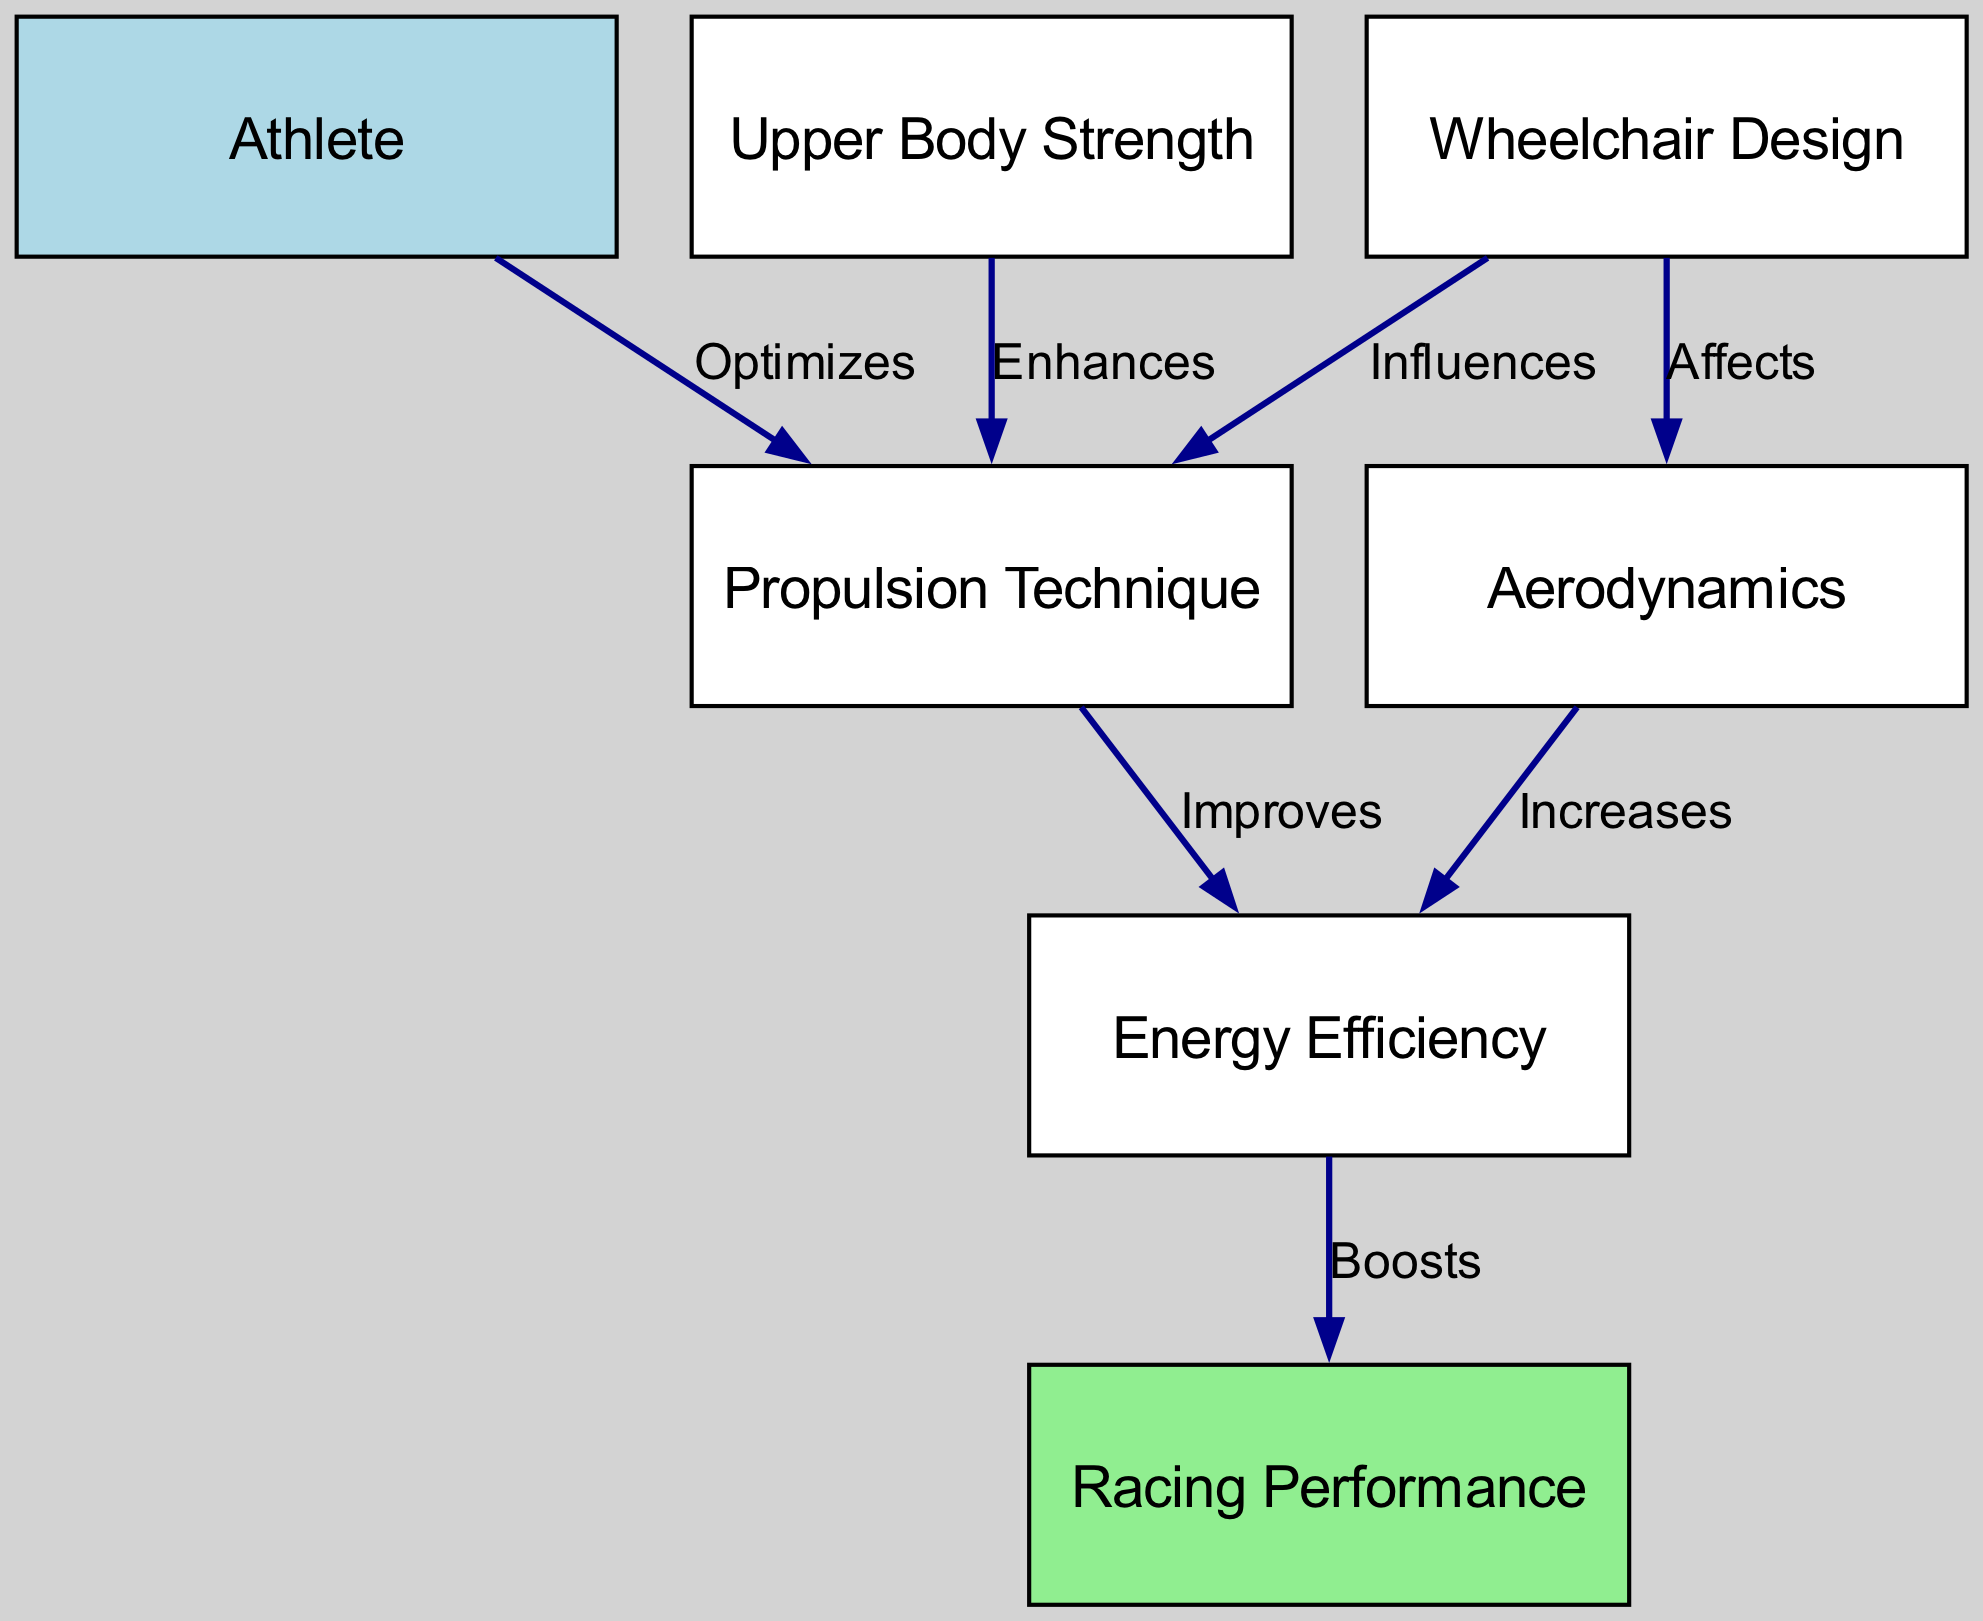What node represents the athlete? In the diagram, the node labeled "Athlete" has the ID "1". Thus, it directly represents the athlete in wheelchair racing.
Answer: Athlete How many nodes are present in the diagram? The diagram contains seven nodes that represent various components involved in wheelchair racing biomechanics.
Answer: Seven Which node influences the propulsion technique? The "Wheelchair Design" node, with ID "2", influences the "Propulsion Technique" node, as indicated by the edge labeled "Influences" connecting them.
Answer: Wheelchair Design What aspect does upper body strength enhance? Upper Body Strength enhances the Propulsion Technique, based on the edge labeled "Enhances" that connects Upper Body Strength to Propulsion Technique.
Answer: Propulsion Technique What is the relationship between aerodynamics and energy efficiency? The relationship is that aerodynamics increases energy efficiency, shown by the edge labeled "Increases" connecting Aerodynamics to Energy Efficiency.
Answer: Increases Which factor boosts racing performance? Energy Efficiency boosts racing performance, as indicated by the edge labeled "Boosts" linking Energy Efficiency to Racing Performance.
Answer: Energy Efficiency If the wheelchair design affects aerodynamics, what can we infer about the design? Since the "Wheelchair Design" node affects aerodynamics, we can infer that a well-designed wheelchair can enhance aerodynamic properties, leading to improved performance in races.
Answer: Well-designed What is the direct effect of propulsion technique on energy efficiency? The propulsion technique improves energy efficiency, as shown by the directed edge "Improves" from Propulsion Technique to Energy Efficiency.
Answer: Improves Which two nodes are linked by the label 'Optimizes'? The label 'Optimizes' connects the nodes for Athlete and Propulsion Technique, indicating a direct optimization relationship.
Answer: Athlete and Propulsion Technique 